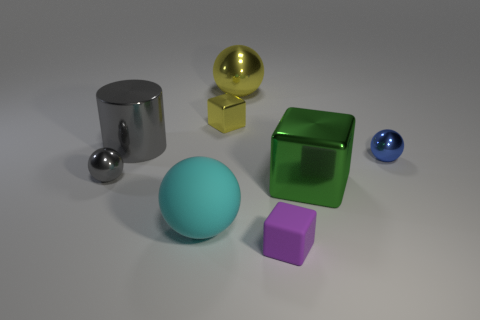Add 2 small red cylinders. How many objects exist? 10 Subtract all yellow cubes. Subtract all yellow balls. How many cubes are left? 2 Subtract all cubes. How many objects are left? 5 Subtract all tiny purple matte things. Subtract all tiny metal things. How many objects are left? 4 Add 1 gray shiny spheres. How many gray shiny spheres are left? 2 Add 4 large gray matte spheres. How many large gray matte spheres exist? 4 Subtract 0 brown spheres. How many objects are left? 8 